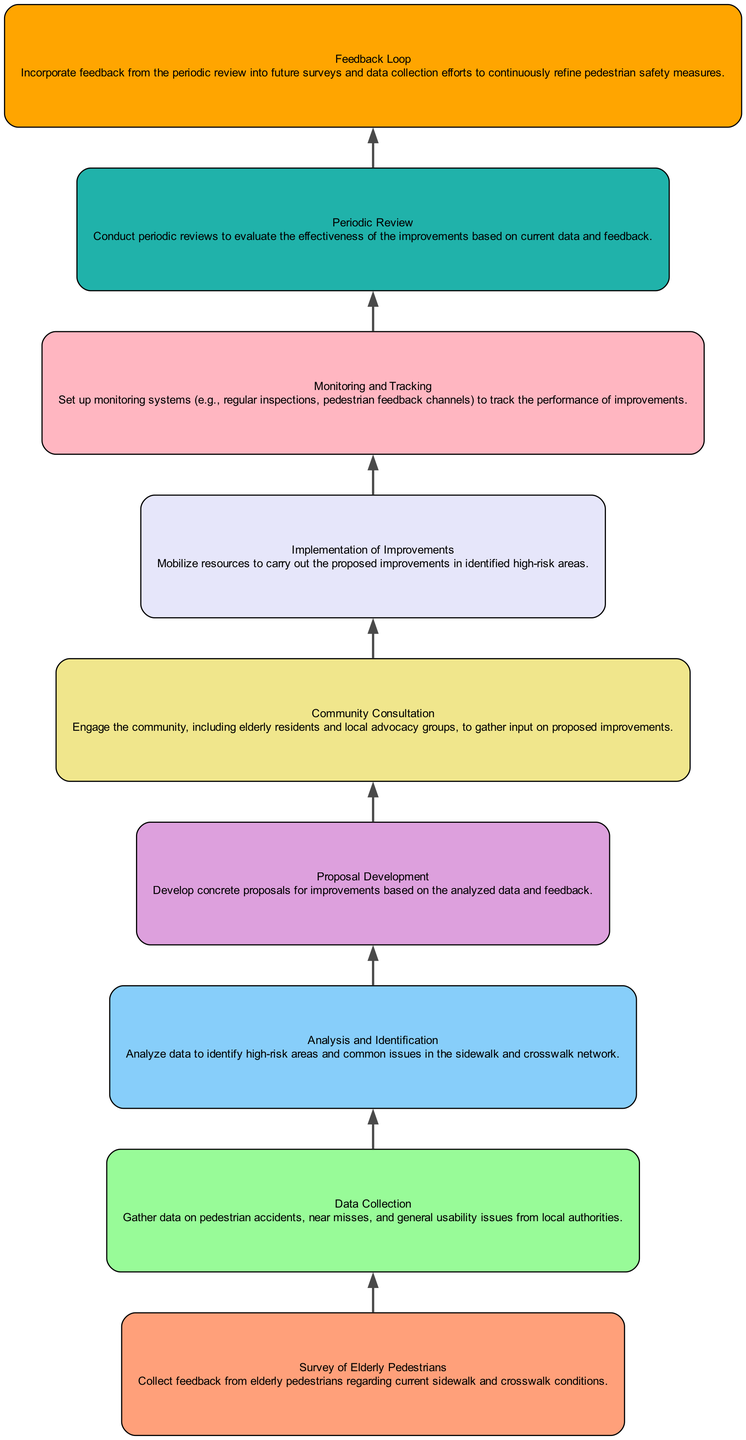What is the first step in the flow? The first step, starting from the bottom, is "Survey of Elderly Pedestrians," which is focused on collecting feedback about current conditions.
Answer: Survey of Elderly Pedestrians How many nodes are present in the diagram? The diagram contains a total of nine nodes, each representing a step in the performance monitoring and feedback loop process.
Answer: Nine What is the last step in the flow? The final step in the flow is "Feedback Loop," which aims to incorporate feedback from periodic reviews into future efforts.
Answer: Feedback Loop What does "Monitoring and Tracking" involve? "Monitoring and Tracking" involves setting up systems for regular inspections and pedestrian feedback channels to evaluate the improvements' performance.
Answer: Monitoring systems Which step follows "Community Consultation"? The step that follows "Community Consultation" is "Implementation of Improvements," which involves mobilizing resources for the proposals.
Answer: Implementation of Improvements What kind of data is gathered in "Data Collection"? In "Data Collection," data on pedestrian accidents, near misses, and usability issues is gathered from local authorities.
Answer: Pedestrian accidents data Name the node that directly leads to "Proposal Development". The node that directly leads to "Proposal Development" is "Analysis and Identification," where data is analyzed to identify issues and high-risk areas.
Answer: Analysis and Identification How does the "Periodic Review" relate to the "Feedback Loop"? "Periodic Review" evaluates the effectiveness of improvements and provides insights that are then incorporated into the "Feedback Loop" for continuous refinement.
Answer: Continuous refinement In terms of sequence, what comes after "Implementation of Improvements"? Following "Implementation of Improvements," the next step is "Monitoring and Tracking," to assess how well the improvements are performing.
Answer: Monitoring and Tracking 